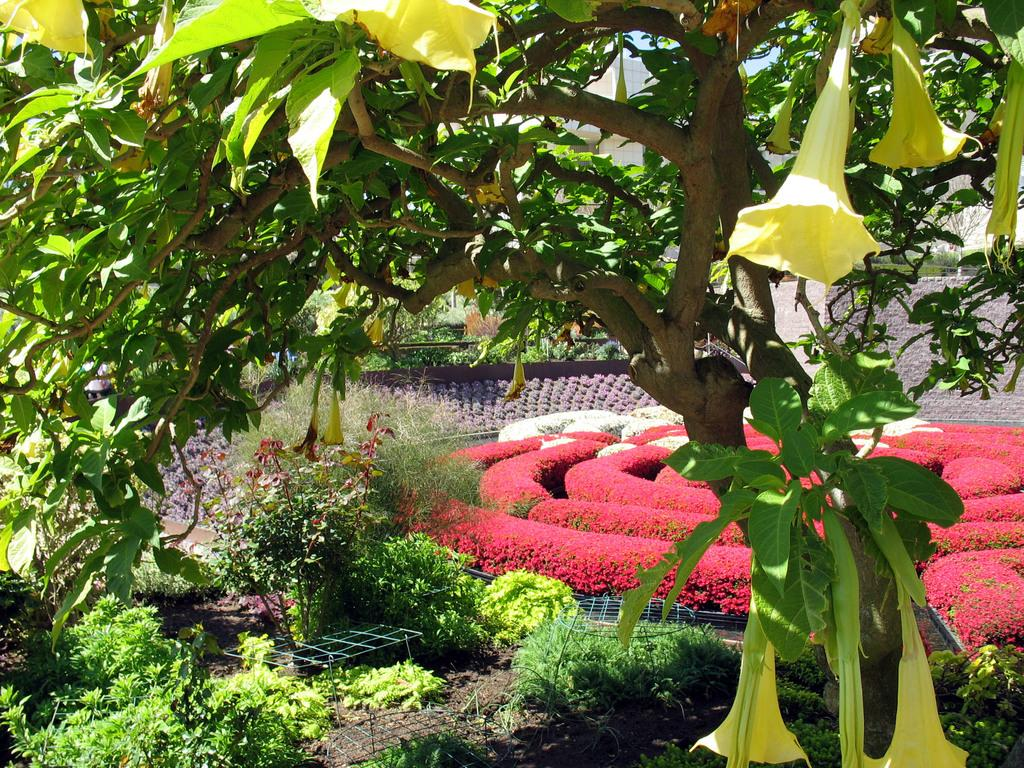What type of vegetation can be seen in the image? There are plants, trees, and flowers in the image. What colors are the flowers in the image? The flowers have white and red colors. What memories do the flowers evoke for the person in the image? There is no person present in the image, so it is not possible to determine any memories associated with the flowers. 